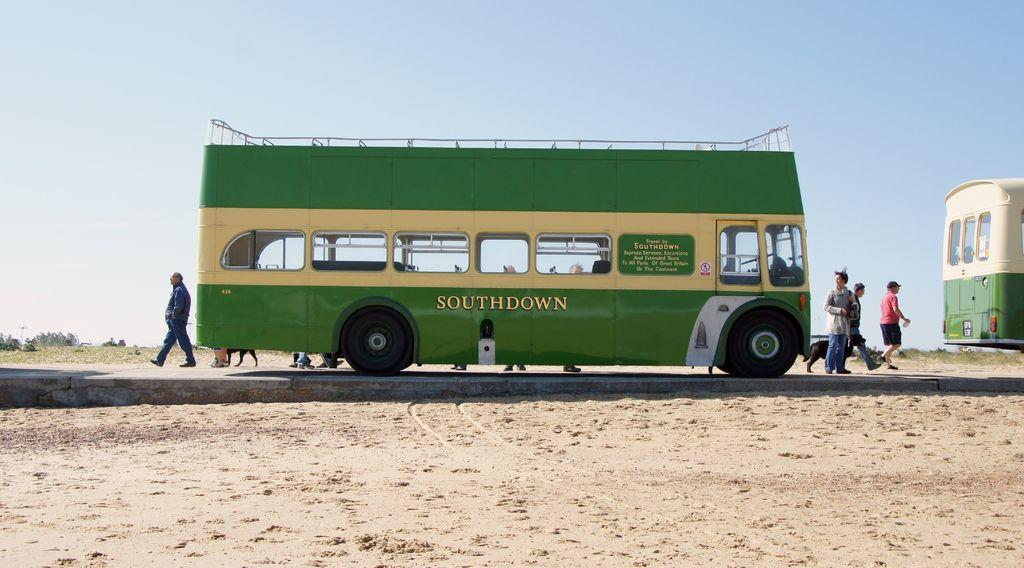<image>
Create a compact narrative representing the image presented. A green and yellow bus that has Southdown written on the side parked on a road 